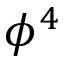<formula> <loc_0><loc_0><loc_500><loc_500>\phi ^ { 4 }</formula> 